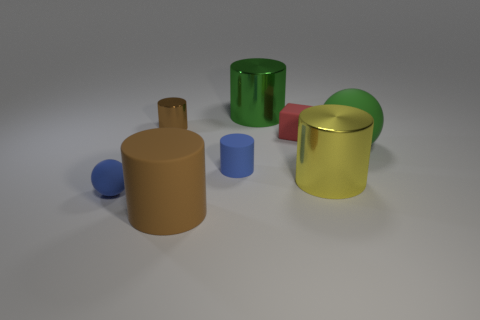There is another cylinder that is the same color as the small shiny cylinder; what is its material?
Your answer should be very brief. Rubber. How many other objects are there of the same color as the small shiny cylinder?
Make the answer very short. 1. There is a tiny blue matte thing that is behind the blue rubber ball; are there any cylinders that are left of it?
Ensure brevity in your answer.  Yes. How big is the brown cylinder that is behind the tiny matte object that is on the right side of the green object behind the large green ball?
Give a very brief answer. Small. What material is the tiny cylinder that is on the left side of the brown thing that is in front of the large matte ball made of?
Your response must be concise. Metal. Is there another big metal object that has the same shape as the large yellow metal object?
Provide a short and direct response. Yes. What is the shape of the yellow shiny thing?
Your answer should be compact. Cylinder. What is the material of the cylinder that is right of the green thing that is behind the rubber sphere on the right side of the brown rubber object?
Offer a terse response. Metal. Is the number of tiny brown objects that are to the right of the tiny blue cylinder greater than the number of big matte cylinders?
Offer a terse response. No. There is a sphere that is the same size as the matte block; what is it made of?
Provide a succinct answer. Rubber. 